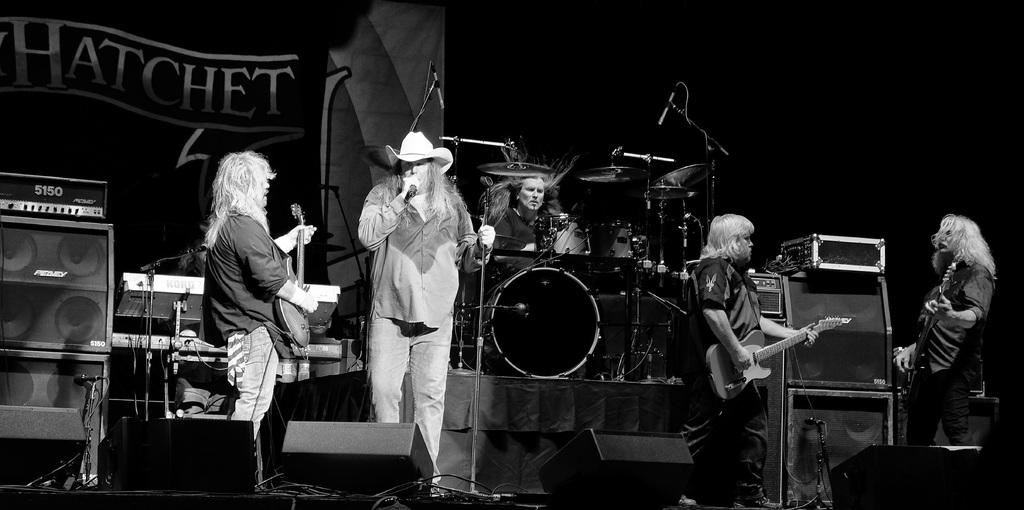How many people are in the image? There are 5 persons in the image. What are some of the persons holding? Three of the persons are holding guitars, and one person is holding a microphone. What can be seen in the background of the image? There are speakers visible in the background, and there is a man with drums in the background. What type of equipment is present in the background? There is an equipment present in the background, but it is not specified what kind. How many friends are sitting on the pot in the image? There is no pot or friends present in the image. What type of flight is the person with the microphone about to take in the image? There is no flight or any indication of travel in the image. 